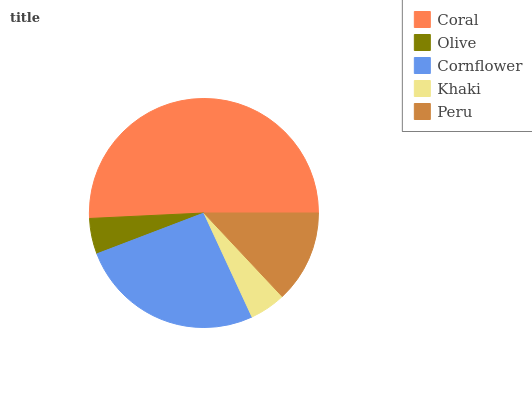Is Olive the minimum?
Answer yes or no. Yes. Is Coral the maximum?
Answer yes or no. Yes. Is Cornflower the minimum?
Answer yes or no. No. Is Cornflower the maximum?
Answer yes or no. No. Is Cornflower greater than Olive?
Answer yes or no. Yes. Is Olive less than Cornflower?
Answer yes or no. Yes. Is Olive greater than Cornflower?
Answer yes or no. No. Is Cornflower less than Olive?
Answer yes or no. No. Is Peru the high median?
Answer yes or no. Yes. Is Peru the low median?
Answer yes or no. Yes. Is Coral the high median?
Answer yes or no. No. Is Olive the low median?
Answer yes or no. No. 